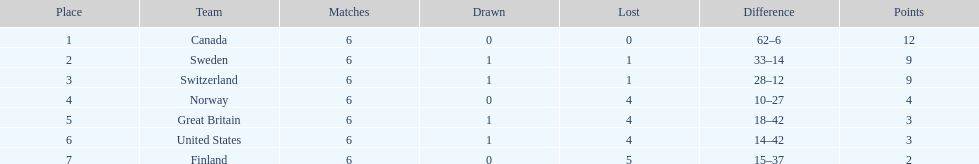Can you parse all the data within this table? {'header': ['Place', 'Team', 'Matches', 'Drawn', 'Lost', 'Difference', 'Points'], 'rows': [['1', 'Canada', '6', '0', '0', '62–6', '12'], ['2', 'Sweden', '6', '1', '1', '33–14', '9'], ['3', 'Switzerland', '6', '1', '1', '28–12', '9'], ['4', 'Norway', '6', '0', '4', '10–27', '4'], ['5', 'Great Britain', '6', '1', '4', '18–42', '3'], ['6', 'United States', '6', '1', '4', '14–42', '3'], ['7', 'Finland', '6', '0', '5', '15–37', '2']]} In the 1951 world ice hockey championships, which nation had a better performance: switzerland or great britain? Switzerland. 